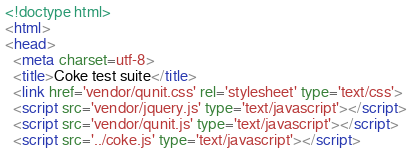Convert code to text. <code><loc_0><loc_0><loc_500><loc_500><_HTML_><!doctype html>
<html>
<head>
  <meta charset=utf-8>
  <title>Coke test suite</title>
  <link href='vendor/qunit.css' rel='stylesheet' type='text/css'>
  <script src='vendor/jquery.js' type='text/javascript'></script>
  <script src='vendor/qunit.js' type='text/javascript'></script>
  <script src='../coke.js' type='text/javascript'></script></code> 